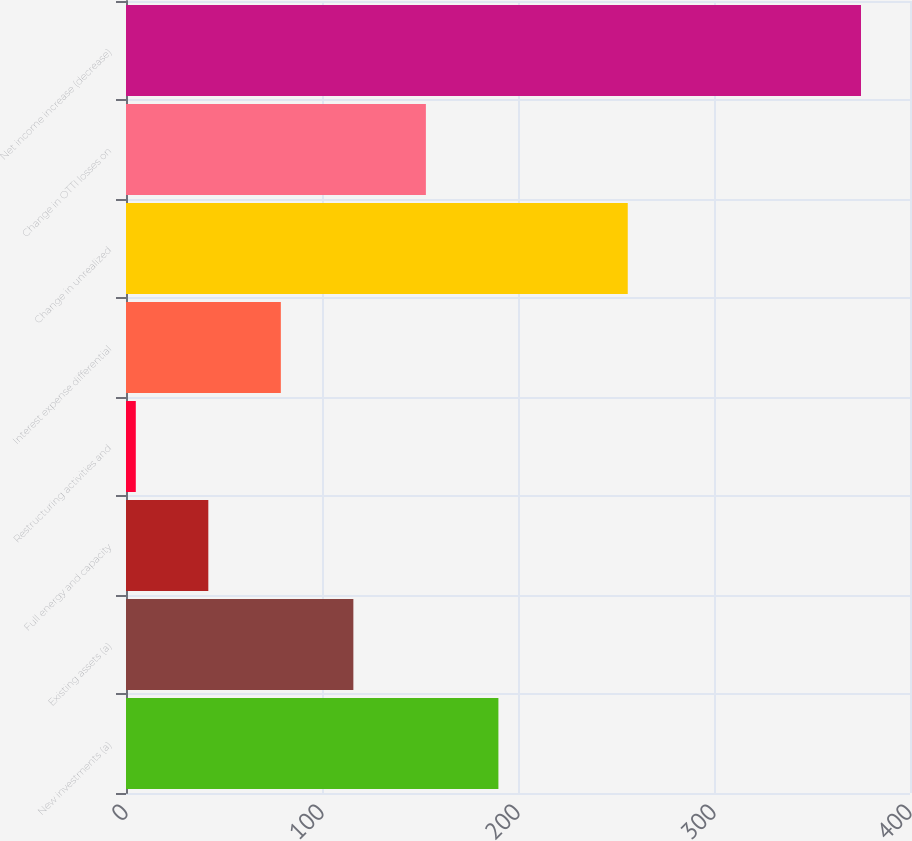<chart> <loc_0><loc_0><loc_500><loc_500><bar_chart><fcel>New investments (a)<fcel>Existing assets (a)<fcel>Full energy and capacity<fcel>Restructuring activities and<fcel>Interest expense differential<fcel>Change in unrealized<fcel>Change in OTTI losses on<fcel>Net income increase (decrease)<nl><fcel>190<fcel>116<fcel>42<fcel>5<fcel>79<fcel>256<fcel>153<fcel>375<nl></chart> 